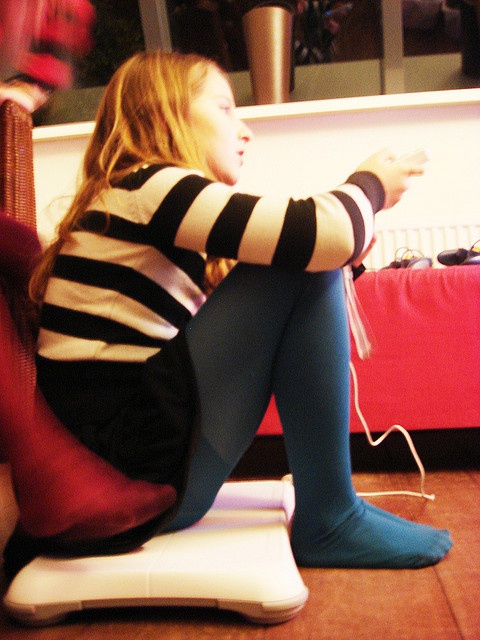Describe the objects in this image and their specific colors. I can see people in maroon, black, tan, ivory, and brown tones, vase in maroon, brown, and tan tones, and remote in beige, maroon, and ivory tones in this image. 